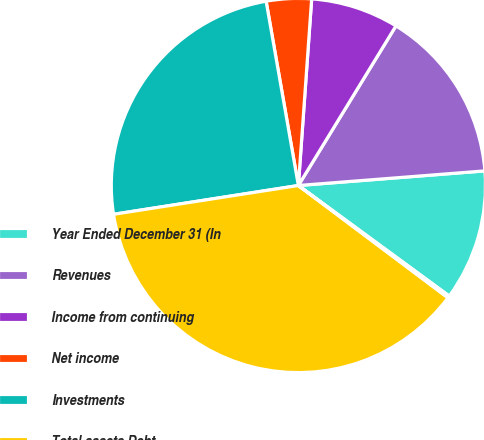<chart> <loc_0><loc_0><loc_500><loc_500><pie_chart><fcel>Year Ended December 31 (In<fcel>Revenues<fcel>Income from continuing<fcel>Net income<fcel>Investments<fcel>Total assets Debt<fcel>Shares outstanding<nl><fcel>11.31%<fcel>15.02%<fcel>7.6%<fcel>3.89%<fcel>24.7%<fcel>37.29%<fcel>0.18%<nl></chart> 